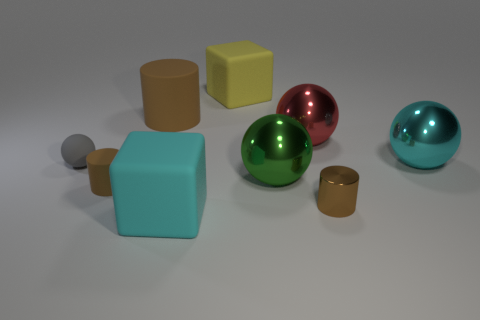Can you describe the textures of the objects? Certainly! The spheres have a smooth and reflective texture, indicating they are likely made from a shiny material such as polished metal or plastic. The cubes, on the other hand, have a matte finish, suggesting a non-reflective material like a painted wood or plastic. 